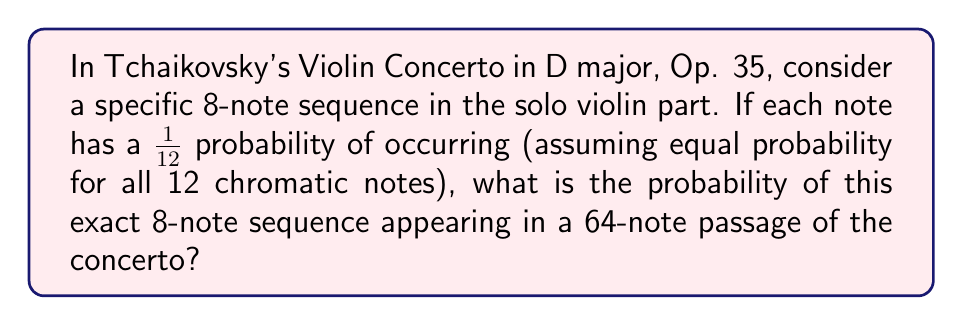Show me your answer to this math problem. Let's approach this step-by-step:

1) First, we need to calculate the probability of the specific 8-note sequence occurring:
   - Each note has a probability of $\frac{1}{12}$
   - For an 8-note sequence, we need all 8 notes to occur in a specific order
   - The probability of this is: $(\frac{1}{12})^8$

2) Now, in a 64-note passage, there are 57 possible starting positions for an 8-note sequence:
   - 64 - 8 + 1 = 57

3) We can model this as a binomial probability problem:
   - We have 57 trials (possible starting positions)
   - We want the probability of the sequence occurring at least once
   - The probability of success on a single trial is $(\frac{1}{12})^8$

4) The probability of the sequence NOT occurring in a single trial is:
   $1 - (\frac{1}{12})^8$

5) The probability of the sequence NOT occurring in any of the 57 trials is:
   $(1 - (\frac{1}{12})^8)^{57}$

6) Therefore, the probability of the sequence occurring at least once is:
   $1 - (1 - (\frac{1}{12})^8)^{57}$

This can be simplified to:

$$1 - (1 - \frac{1}{429,981,696})^{57}$$
Answer: $1 - (1 - \frac{1}{429,981,696})^{57} \approx 1.33 \times 10^{-7}$ 